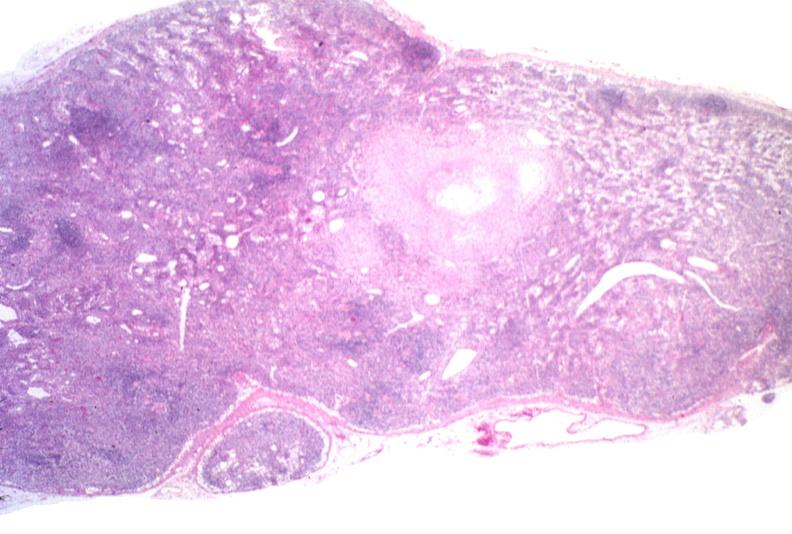does this image show lymph node, cryptococcosis?
Answer the question using a single word or phrase. Yes 